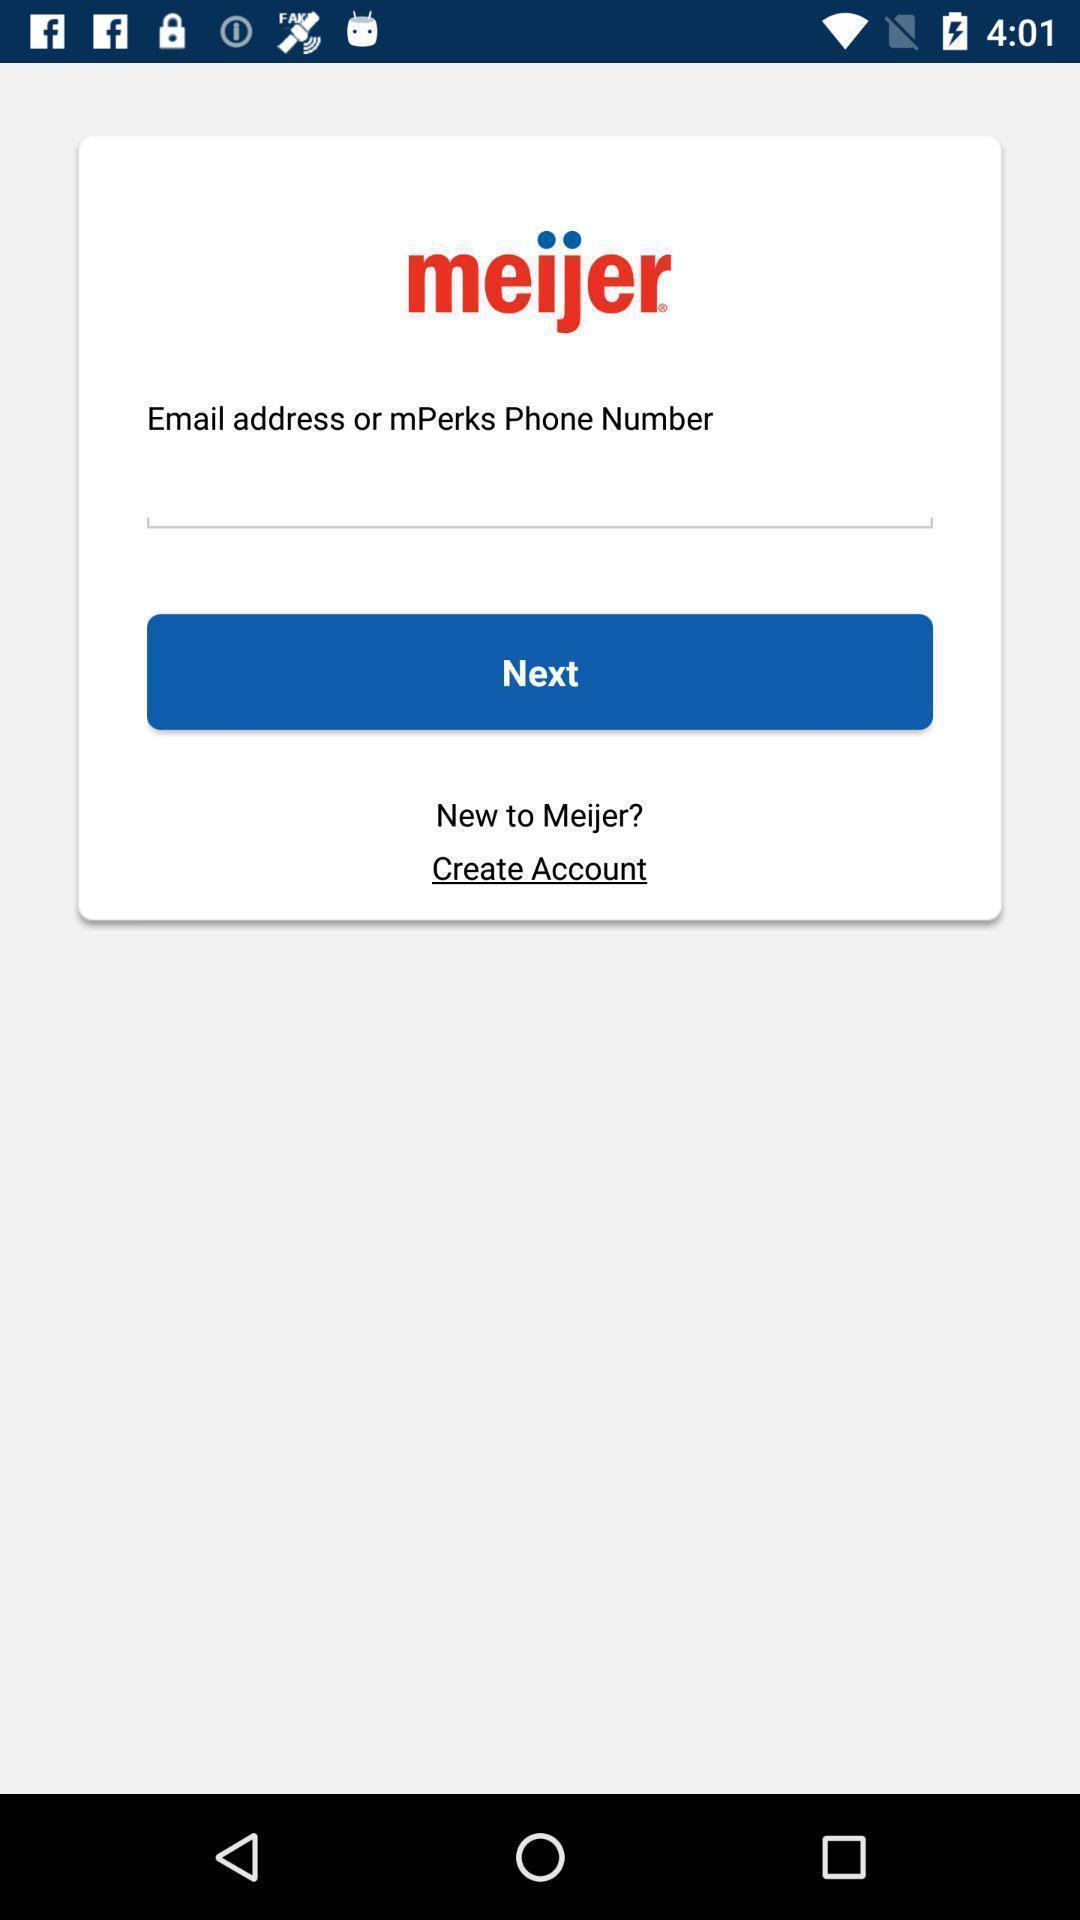Explain the elements present in this screenshot. Screen displaying contents in login page. 